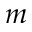<formula> <loc_0><loc_0><loc_500><loc_500>m</formula> 